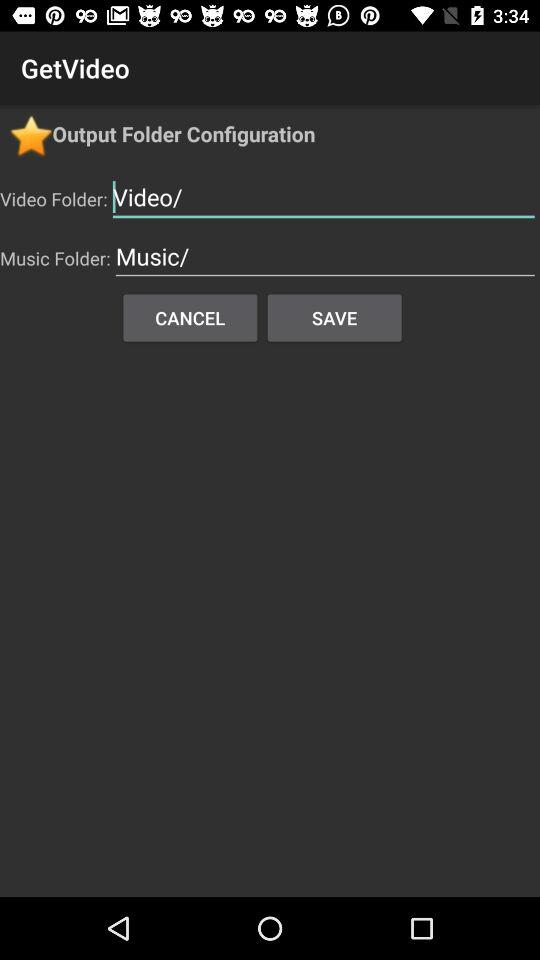What is the application name? The application name is "GetVideo". 